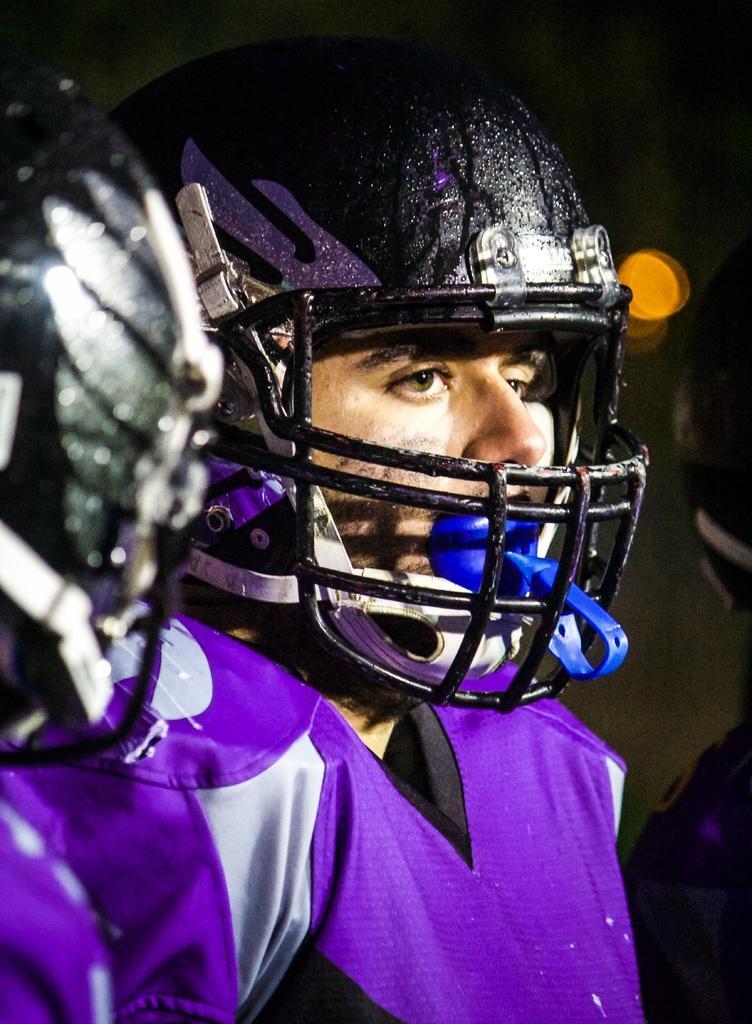How would you summarize this image in a sentence or two? In the image there is a person wearing purple shirt and a helmet. 